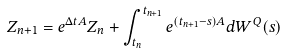Convert formula to latex. <formula><loc_0><loc_0><loc_500><loc_500>Z _ { n + 1 } = e ^ { \Delta t A } Z _ { n } + \int _ { t _ { n } } ^ { t _ { n + 1 } } e ^ { ( t _ { n + 1 } - s ) A } d W ^ { Q } ( s )</formula> 